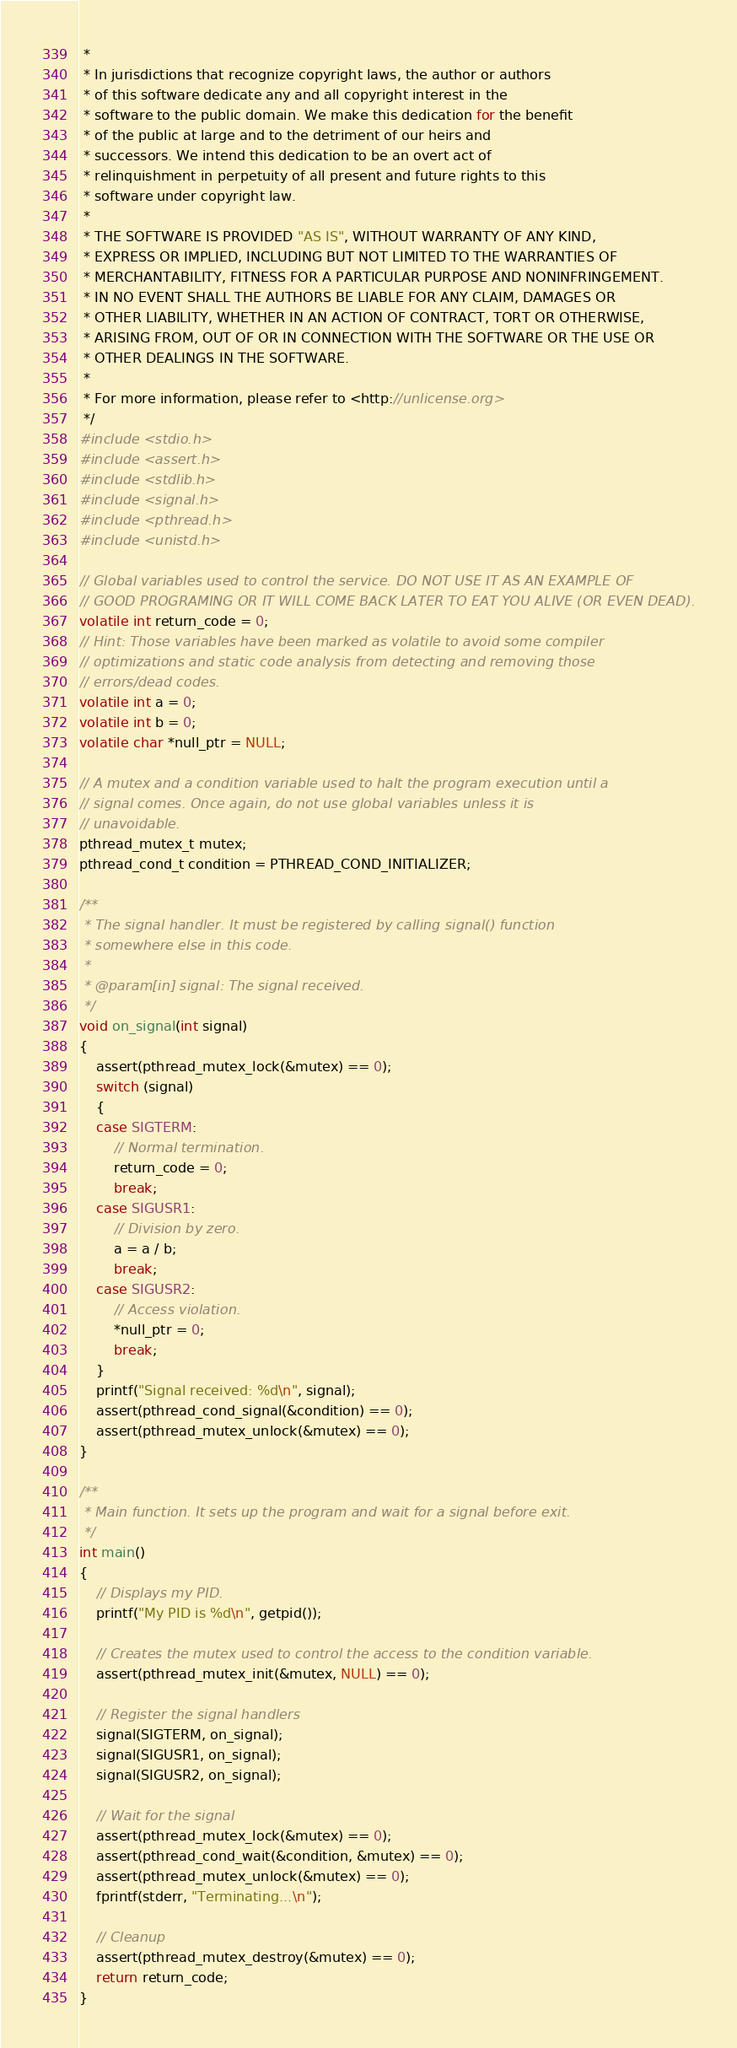Convert code to text. <code><loc_0><loc_0><loc_500><loc_500><_C_> * 
 * In jurisdictions that recognize copyright laws, the author or authors
 * of this software dedicate any and all copyright interest in the
 * software to the public domain. We make this dedication for the benefit
 * of the public at large and to the detriment of our heirs and
 * successors. We intend this dedication to be an overt act of
 * relinquishment in perpetuity of all present and future rights to this
 * software under copyright law.
 * 
 * THE SOFTWARE IS PROVIDED "AS IS", WITHOUT WARRANTY OF ANY KIND,
 * EXPRESS OR IMPLIED, INCLUDING BUT NOT LIMITED TO THE WARRANTIES OF
 * MERCHANTABILITY, FITNESS FOR A PARTICULAR PURPOSE AND NONINFRINGEMENT.
 * IN NO EVENT SHALL THE AUTHORS BE LIABLE FOR ANY CLAIM, DAMAGES OR
 * OTHER LIABILITY, WHETHER IN AN ACTION OF CONTRACT, TORT OR OTHERWISE,
 * ARISING FROM, OUT OF OR IN CONNECTION WITH THE SOFTWARE OR THE USE OR
 * OTHER DEALINGS IN THE SOFTWARE.
 * 
 * For more information, please refer to <http://unlicense.org>
 */
#include <stdio.h>
#include <assert.h>
#include <stdlib.h>
#include <signal.h>
#include <pthread.h>
#include <unistd.h>

// Global variables used to control the service. DO NOT USE IT AS AN EXAMPLE OF
// GOOD PROGRAMING OR IT WILL COME BACK LATER TO EAT YOU ALIVE (OR EVEN DEAD).
volatile int return_code = 0;
// Hint: Those variables have been marked as volatile to avoid some compiler
// optimizations and static code analysis from detecting and removing those
// errors/dead codes.
volatile int a = 0;
volatile int b = 0;
volatile char *null_ptr = NULL;

// A mutex and a condition variable used to halt the program execution until a
// signal comes. Once again, do not use global variables unless it is
// unavoidable.
pthread_mutex_t mutex;
pthread_cond_t condition = PTHREAD_COND_INITIALIZER;

/**
 * The signal handler. It must be registered by calling signal() function
 * somewhere else in this code.
 * 
 * @param[in] signal: The signal received.
 */
void on_signal(int signal)
{
    assert(pthread_mutex_lock(&mutex) == 0);
    switch (signal)
    {
    case SIGTERM:
        // Normal termination.
        return_code = 0;
        break;
    case SIGUSR1:
        // Division by zero.
        a = a / b;
        break;
    case SIGUSR2:
        // Access violation.
        *null_ptr = 0;
        break;
    }
    printf("Signal received: %d\n", signal);
    assert(pthread_cond_signal(&condition) == 0);
    assert(pthread_mutex_unlock(&mutex) == 0);
}

/**
 * Main function. It sets up the program and wait for a signal before exit.
 */
int main()
{
    // Displays my PID.
    printf("My PID is %d\n", getpid());

    // Creates the mutex used to control the access to the condition variable.
    assert(pthread_mutex_init(&mutex, NULL) == 0);

    // Register the signal handlers
    signal(SIGTERM, on_signal);
    signal(SIGUSR1, on_signal);
    signal(SIGUSR2, on_signal);

    // Wait for the signal
    assert(pthread_mutex_lock(&mutex) == 0);
    assert(pthread_cond_wait(&condition, &mutex) == 0);
    assert(pthread_mutex_unlock(&mutex) == 0);
    fprintf(stderr, "Terminating...\n");

    // Cleanup
    assert(pthread_mutex_destroy(&mutex) == 0);
    return return_code;
}</code> 